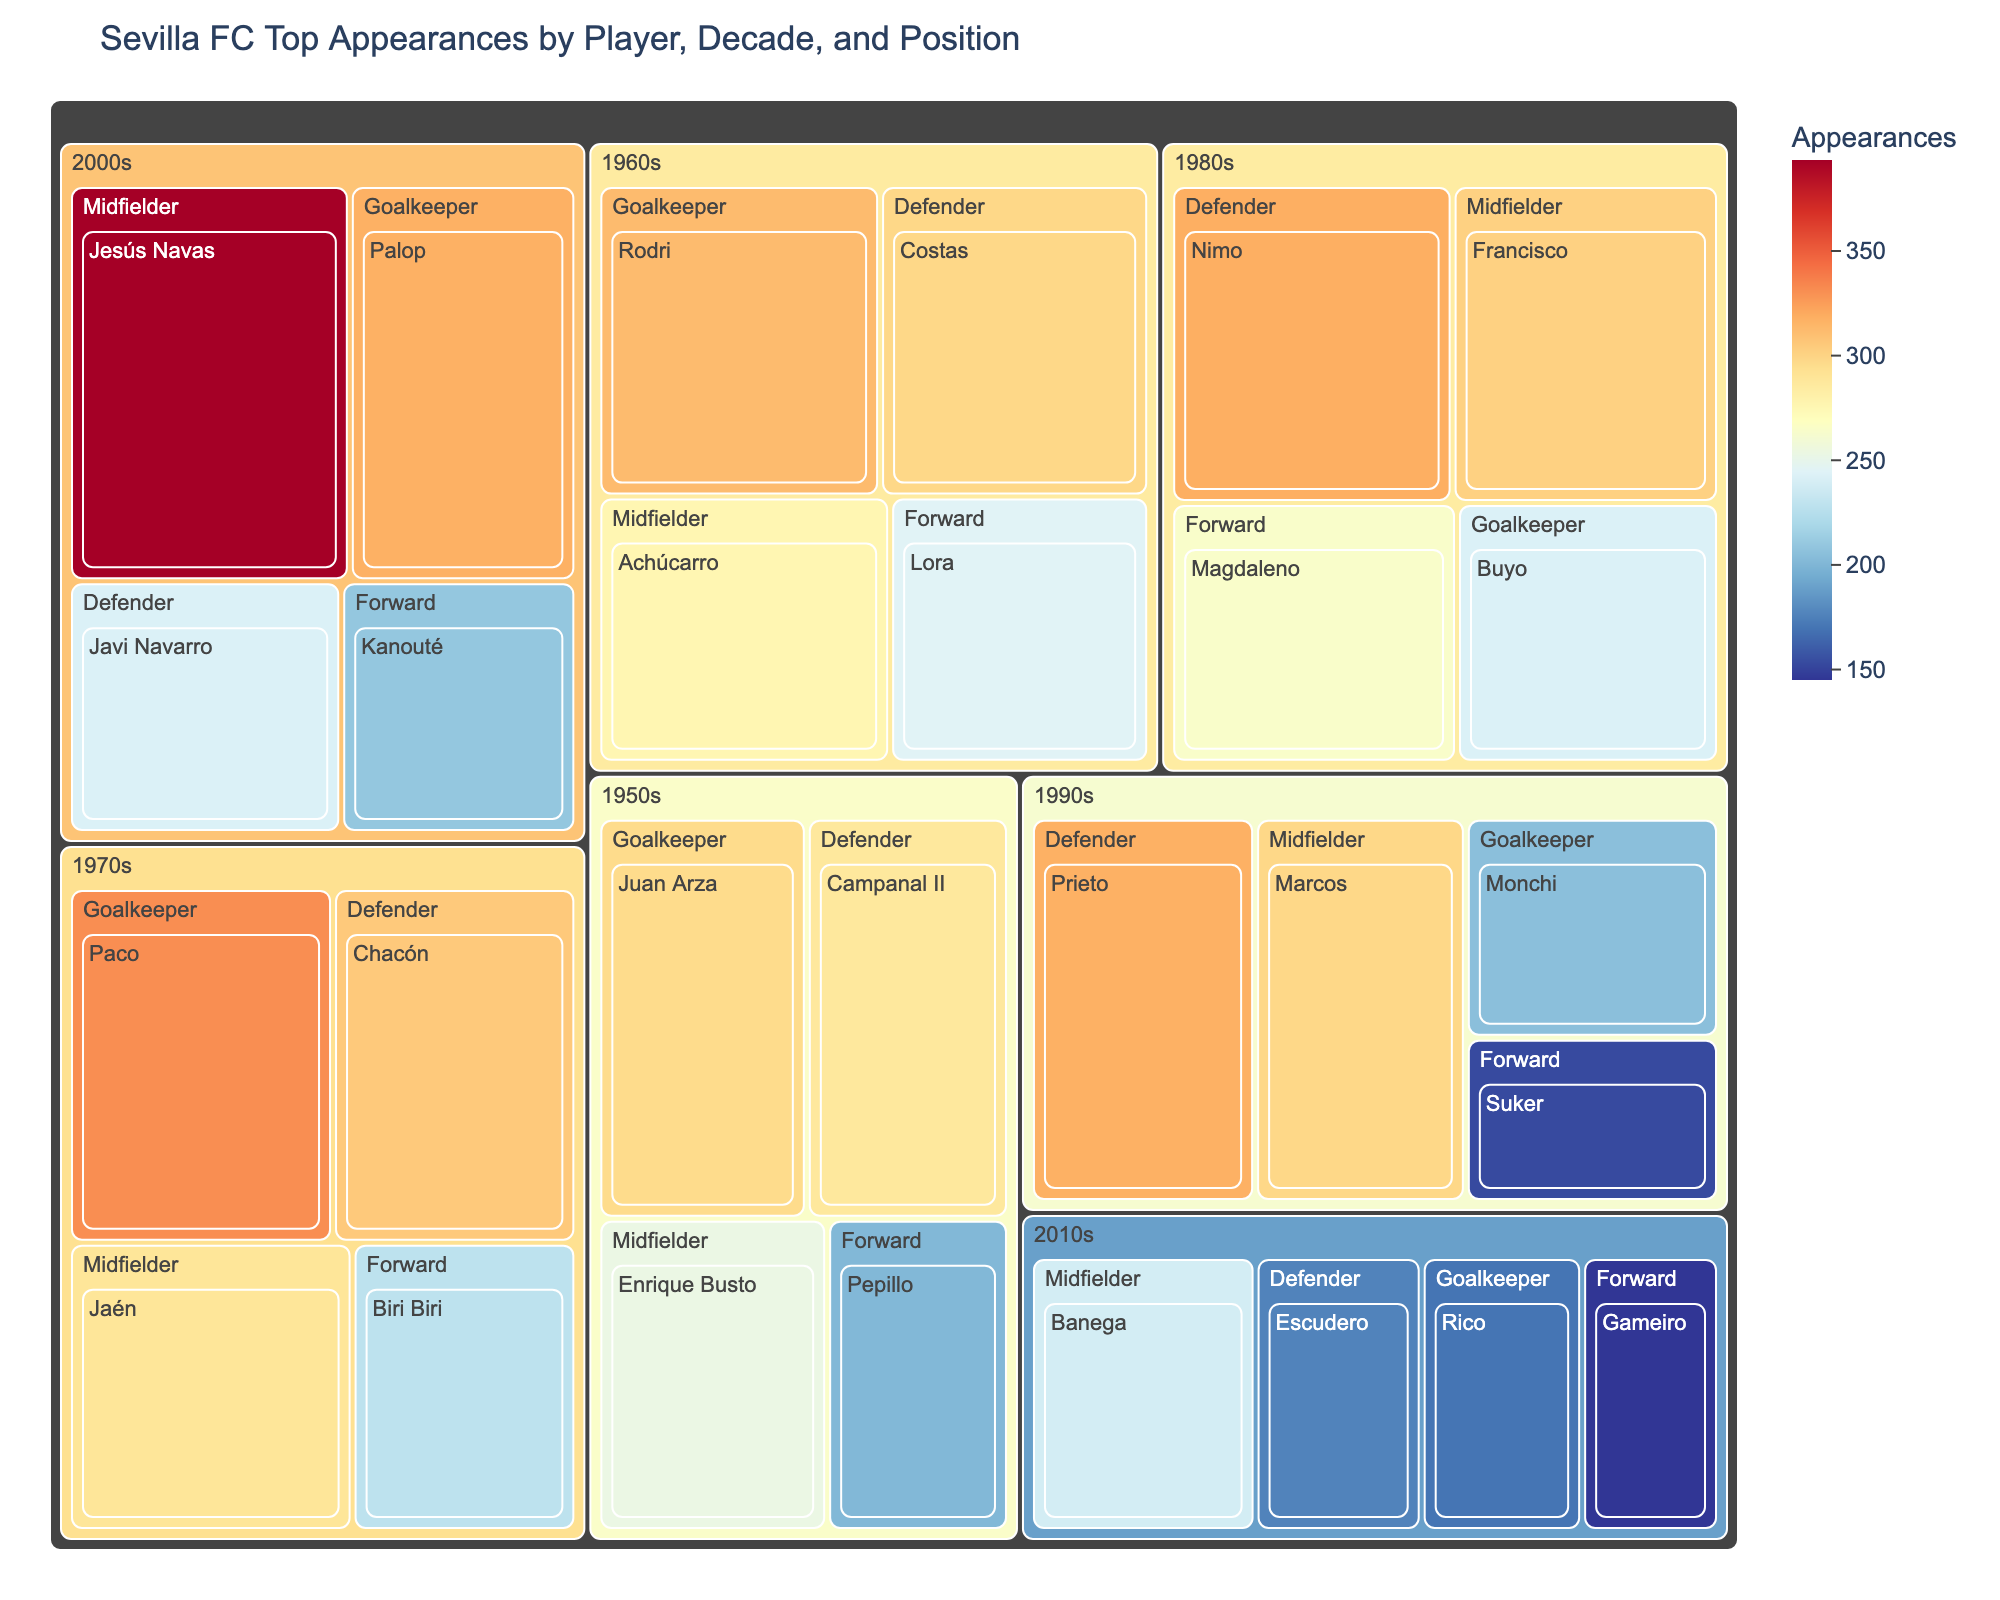Who is the player with the most appearances in the 1970s? In the treemap, find the section for the 1970s. Within that decade, look for the player with the largest rectangular area.
Answer: Paco Which position had the player with the highest appearances overall? Identify the player with the largest area in the entire treemap and note their position.
Answer: Midfielder (Jesús Navas) How many appearances did Jesús Navas make? Locate Jesús Navas in the treemap and refer to the number of appearances displayed.
Answer: 393 Compare the total appearances of the midfielders in the 2000s to those in the 2010s. Which decade has more total appearances? Sum the appearances of midfielders in the 2000s (Jesús Navas) and compare it to the sum of midfielders in the 2010s (Banega).
Answer: 2000s Which decade had the goalkeeper with the fewest appearances? Find the smallest area in the Goalkeeper sections across all decades.
Answer: 2010s (Rico, 170) How does the number of appearances of Suker in the 1990s compare to Kanouté in the 2000s? Find Suker and Kanouté in the treemap and compare their number of appearances.
Answer: Kanouté has more (209 vs 153) What is the average number of appearances for defenders in the 1980s? Sum the appearances for defenders in the 1980s (Nimo) and divide by the number of defenders (1).
Answer: 318 Which player had more appearances, Rodri in the 1960s or Juan Arza in the 1950s? Find Rodri and Juan Arza in the treemap and compare their number of appearances.
Answer: Rodri (312 vs 296) Who made more appearances as a forward in the 1980s, Magdaleno or Biri Biri in the 1970s? Locate Magdaleno in the 1980s and Biri Biri in the 1970s and compare their appearances.
Answer: Magdaleno (264 vs 228) What is the total number of appearances for all goalkeepers listed across all decades? Sum the appearances of all players in the Goalkeeper sections across all decades: Juan Arza (296), Rodri (312), Paco (331), Buyo (242), Monchi (205), Palop (317), Rico (170).
Answer: 1873 